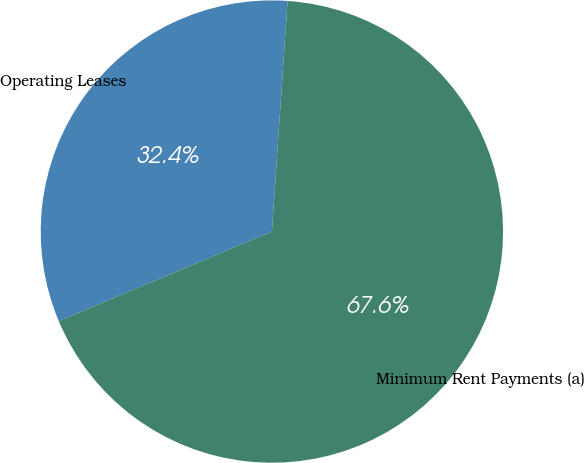Convert chart to OTSL. <chart><loc_0><loc_0><loc_500><loc_500><pie_chart><fcel>Operating Leases<fcel>Minimum Rent Payments (a)<nl><fcel>32.41%<fcel>67.59%<nl></chart> 